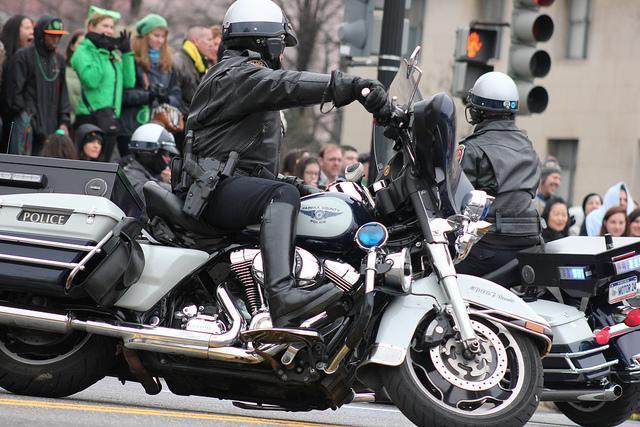How many motorcycles can be seen?
Give a very brief answer. 2. How many people are visible?
Give a very brief answer. 7. How many giraffes are leaning over the woman's left shoulder?
Give a very brief answer. 0. 